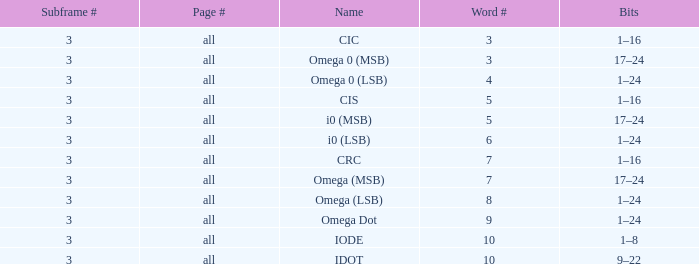What is the word count that is named omega dot? 9.0. I'm looking to parse the entire table for insights. Could you assist me with that? {'header': ['Subframe #', 'Page #', 'Name', 'Word #', 'Bits'], 'rows': [['3', 'all', 'CIC', '3', '1–16'], ['3', 'all', 'Omega 0 (MSB)', '3', '17–24'], ['3', 'all', 'Omega 0 (LSB)', '4', '1–24'], ['3', 'all', 'CIS', '5', '1–16'], ['3', 'all', 'i0 (MSB)', '5', '17–24'], ['3', 'all', 'i0 (LSB)', '6', '1–24'], ['3', 'all', 'CRC', '7', '1–16'], ['3', 'all', 'Omega (MSB)', '7', '17–24'], ['3', 'all', 'Omega (LSB)', '8', '1–24'], ['3', 'all', 'Omega Dot', '9', '1–24'], ['3', 'all', 'IODE', '10', '1–8'], ['3', 'all', 'IDOT', '10', '9–22']]} 